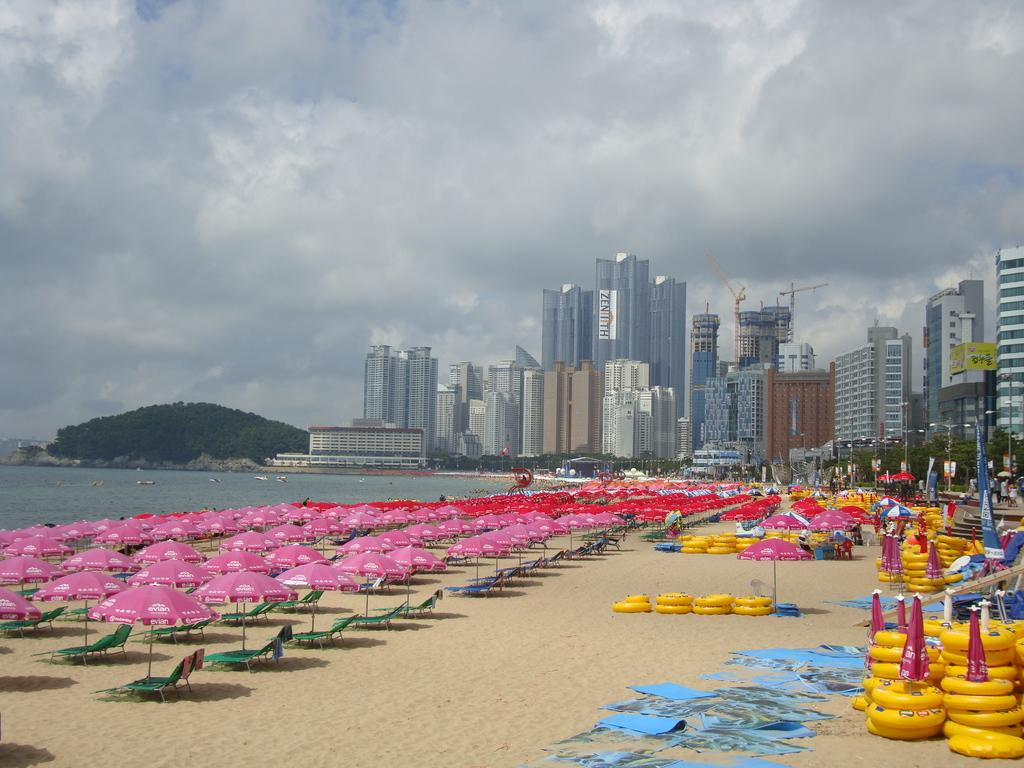What type of furniture is present in the image? There are chairs in the image. What objects are present to provide shade? There are umbrellas in the image. What type of structures can be seen in the image? There are buildings in the image. What type of vegetation is present in the image? There are trees in the image. What natural element is visible in the image? There is water visible in the image. What is visible in the background of the image? The sky is visible in the background of the image. What color objects are present on the ground? There are yellow color objects on the ground. What type of weather can be seen in the image? The provided facts do not mention any weather conditions, so it cannot be determined from the image. What is the base of the umbrellas made of in the image? The provided facts do not mention the material or base of the umbrellas, so it cannot be determined from the image. 